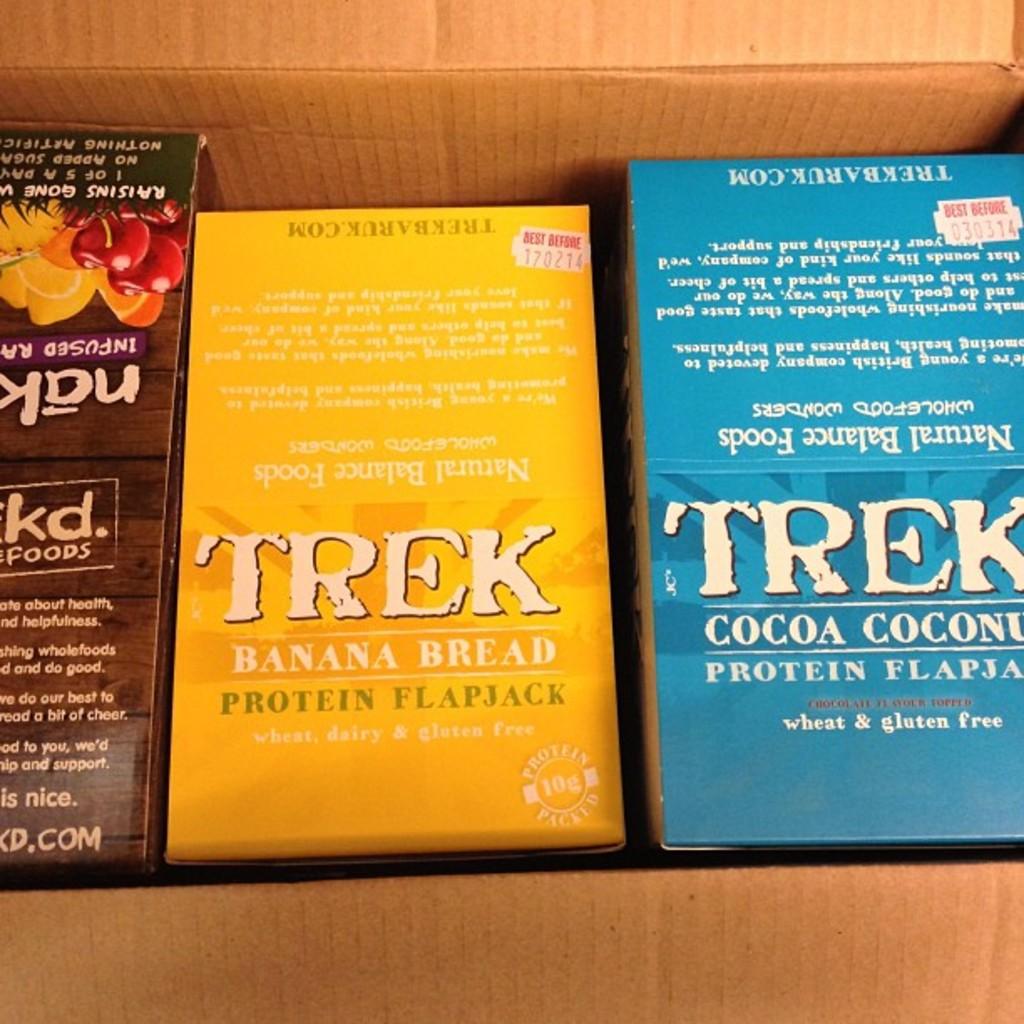What flavor does the yellow box contain?
Your answer should be very brief. Banana bread. What is the brand of this protein flapjack?
Your answer should be compact. Trek. 